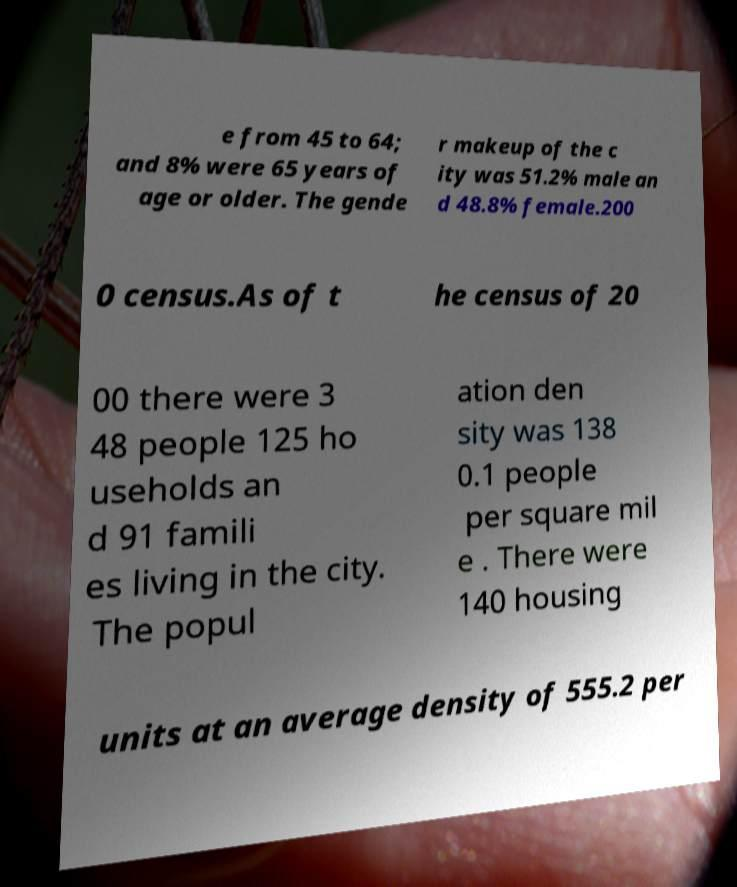Could you extract and type out the text from this image? e from 45 to 64; and 8% were 65 years of age or older. The gende r makeup of the c ity was 51.2% male an d 48.8% female.200 0 census.As of t he census of 20 00 there were 3 48 people 125 ho useholds an d 91 famili es living in the city. The popul ation den sity was 138 0.1 people per square mil e . There were 140 housing units at an average density of 555.2 per 